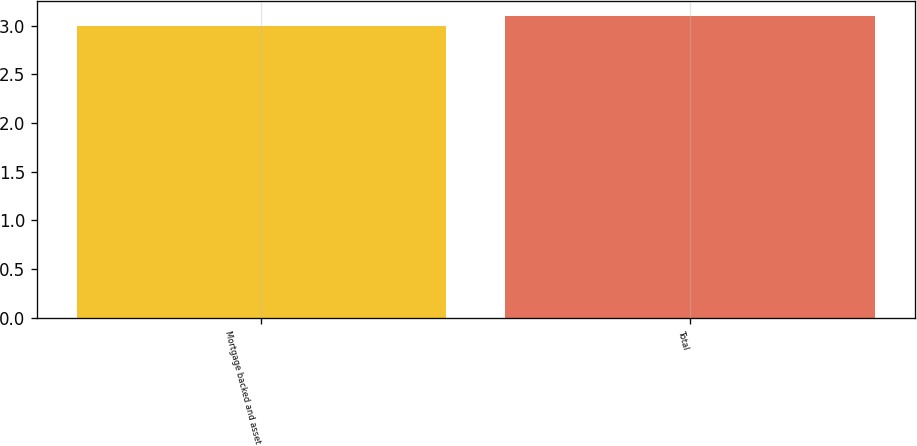Convert chart to OTSL. <chart><loc_0><loc_0><loc_500><loc_500><bar_chart><fcel>Mortgage backed and asset<fcel>Total<nl><fcel>3<fcel>3.1<nl></chart> 